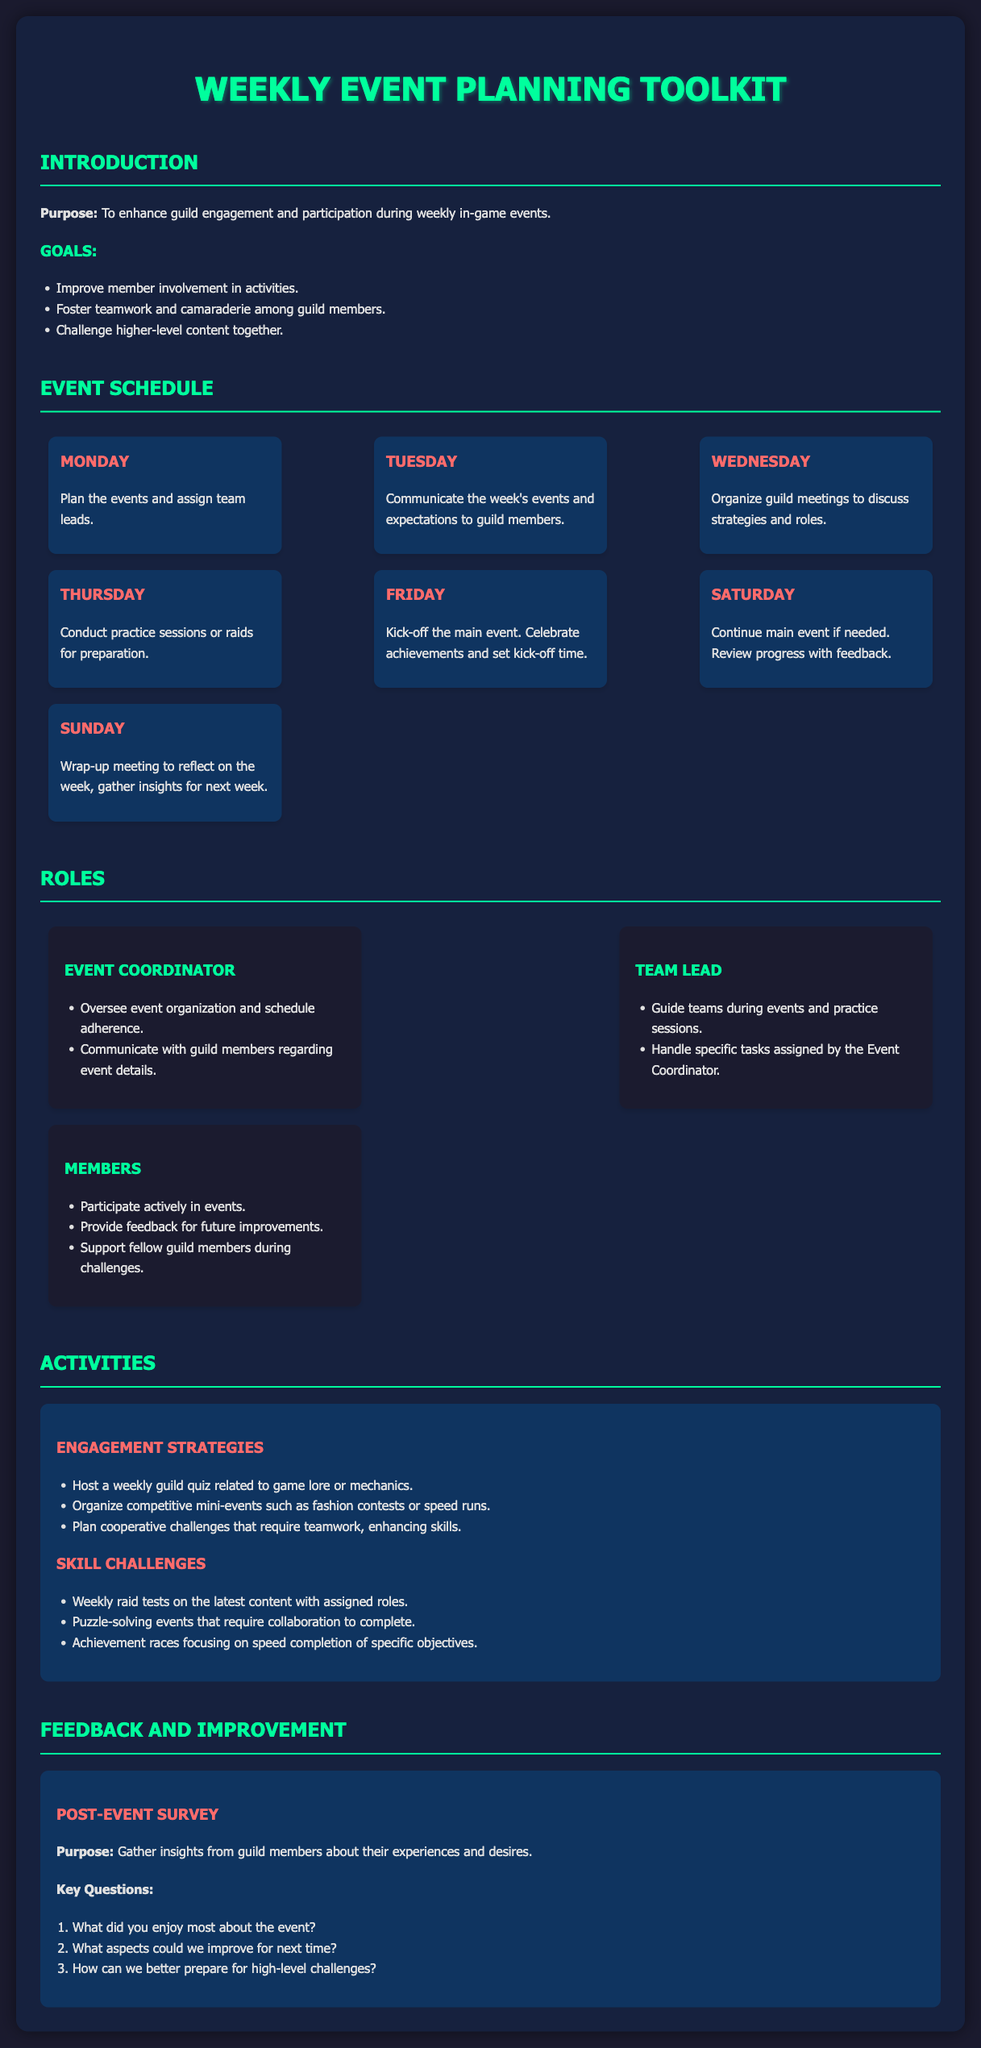What is the purpose of the toolkit? The purpose is to enhance guild engagement and participation during weekly in-game events.
Answer: Enhance guild engagement What is the main activity planned for Friday? The main activity on Friday is to kick-off the main event and celebrate achievements.
Answer: Kick-off the main event Who oversees event organization? The role responsible for overseeing event organization is the Event Coordinator.
Answer: Event Coordinator What day is dedicated to practice sessions? Practice sessions are scheduled for Thursday.
Answer: Thursday How many key questions are in the post-event survey? The post-event survey includes three key questions.
Answer: Three What type of mini-event is mentioned under engagement strategies? A type of mini-event mentioned is fashion contests.
Answer: Fashion contests What is a role of the Team Lead? The Team Lead guides teams during events and practice sessions.
Answer: Guide teams What type of events helps improve skills through teamwork? Cooperative challenges enhance skills through teamwork.
Answer: Cooperative challenges When is the wrap-up meeting scheduled? The wrap-up meeting is scheduled for Sunday.
Answer: Sunday 